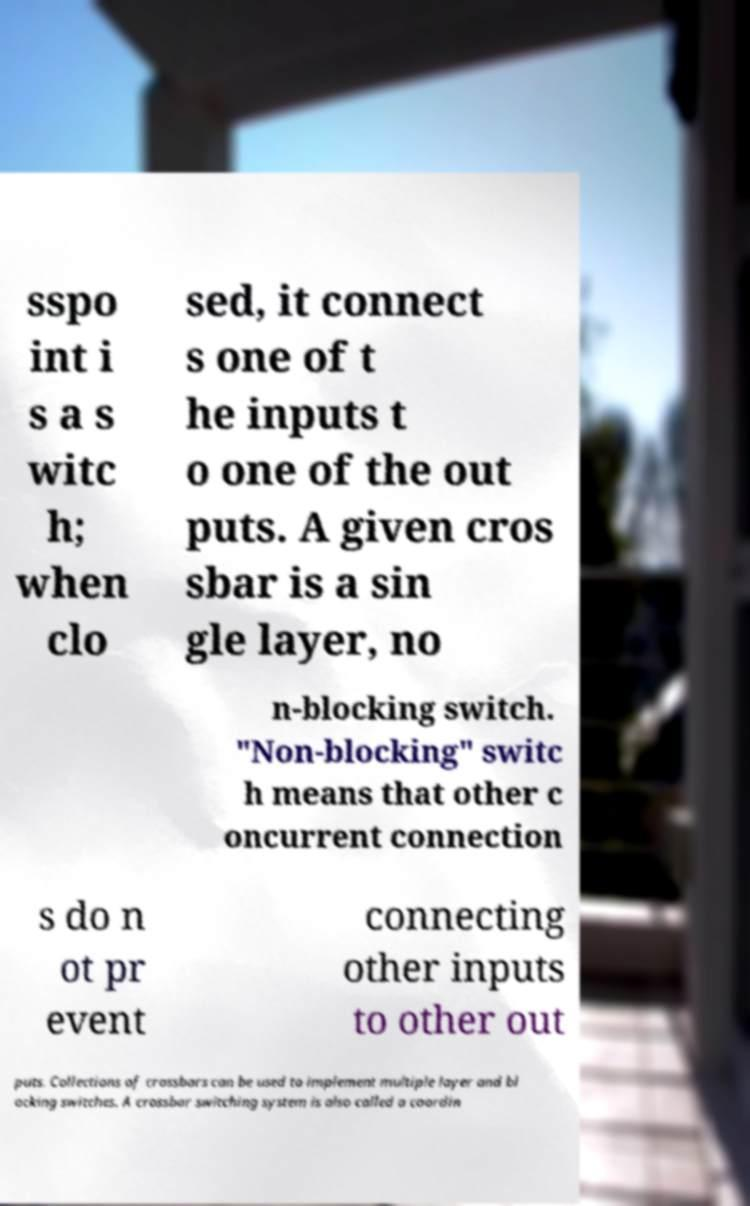Could you extract and type out the text from this image? sspo int i s a s witc h; when clo sed, it connect s one of t he inputs t o one of the out puts. A given cros sbar is a sin gle layer, no n-blocking switch. "Non-blocking" switc h means that other c oncurrent connection s do n ot pr event connecting other inputs to other out puts. Collections of crossbars can be used to implement multiple layer and bl ocking switches. A crossbar switching system is also called a coordin 